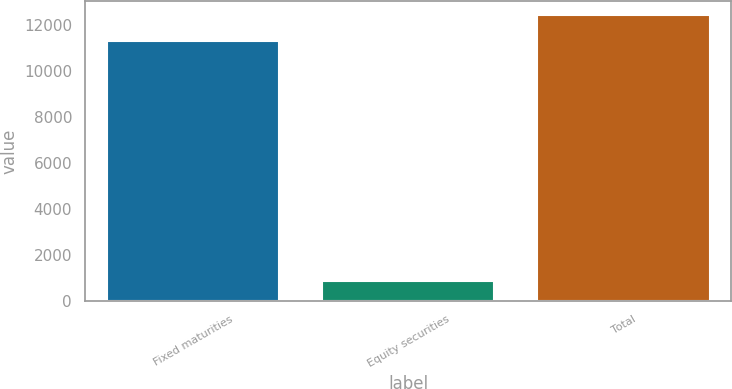Convert chart to OTSL. <chart><loc_0><loc_0><loc_500><loc_500><bar_chart><fcel>Fixed maturities<fcel>Equity securities<fcel>Total<nl><fcel>11273<fcel>870<fcel>12400.3<nl></chart> 